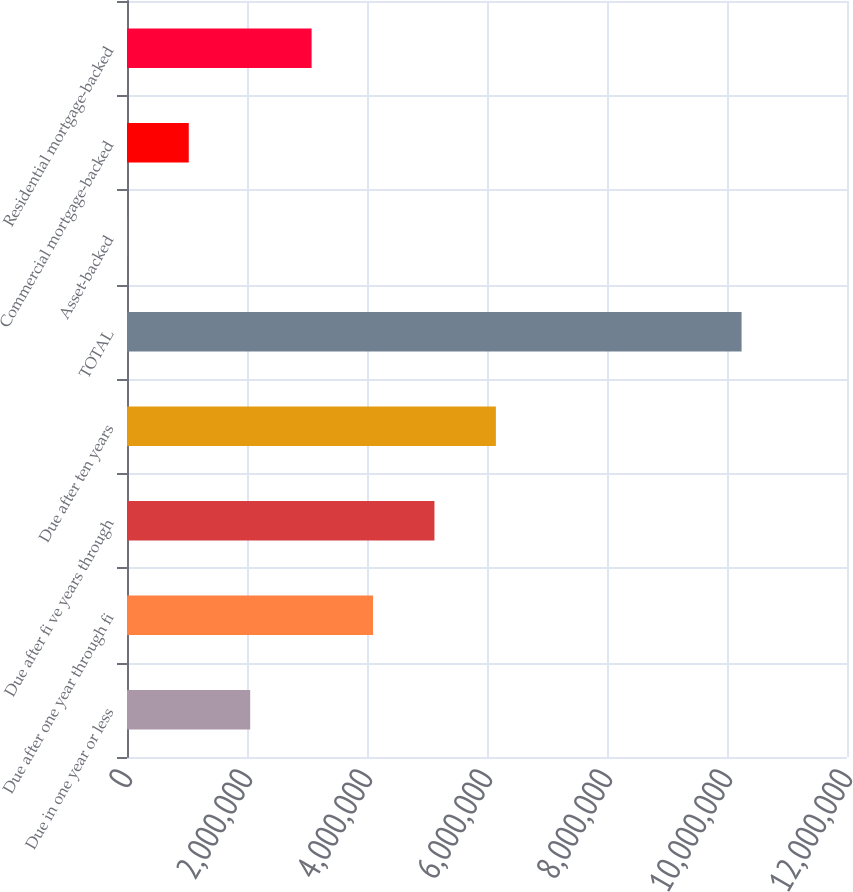Convert chart to OTSL. <chart><loc_0><loc_0><loc_500><loc_500><bar_chart><fcel>Due in one year or less<fcel>Due after one year through fi<fcel>Due after fi ve years through<fcel>Due after ten years<fcel>TOTAL<fcel>Asset-backed<fcel>Commercial mortgage-backed<fcel>Residential mortgage-backed<nl><fcel>2.053e+06<fcel>4.10048e+06<fcel>5.12422e+06<fcel>6.14796e+06<fcel>1.02429e+07<fcel>5519<fcel>1.02926e+06<fcel>3.07674e+06<nl></chart> 